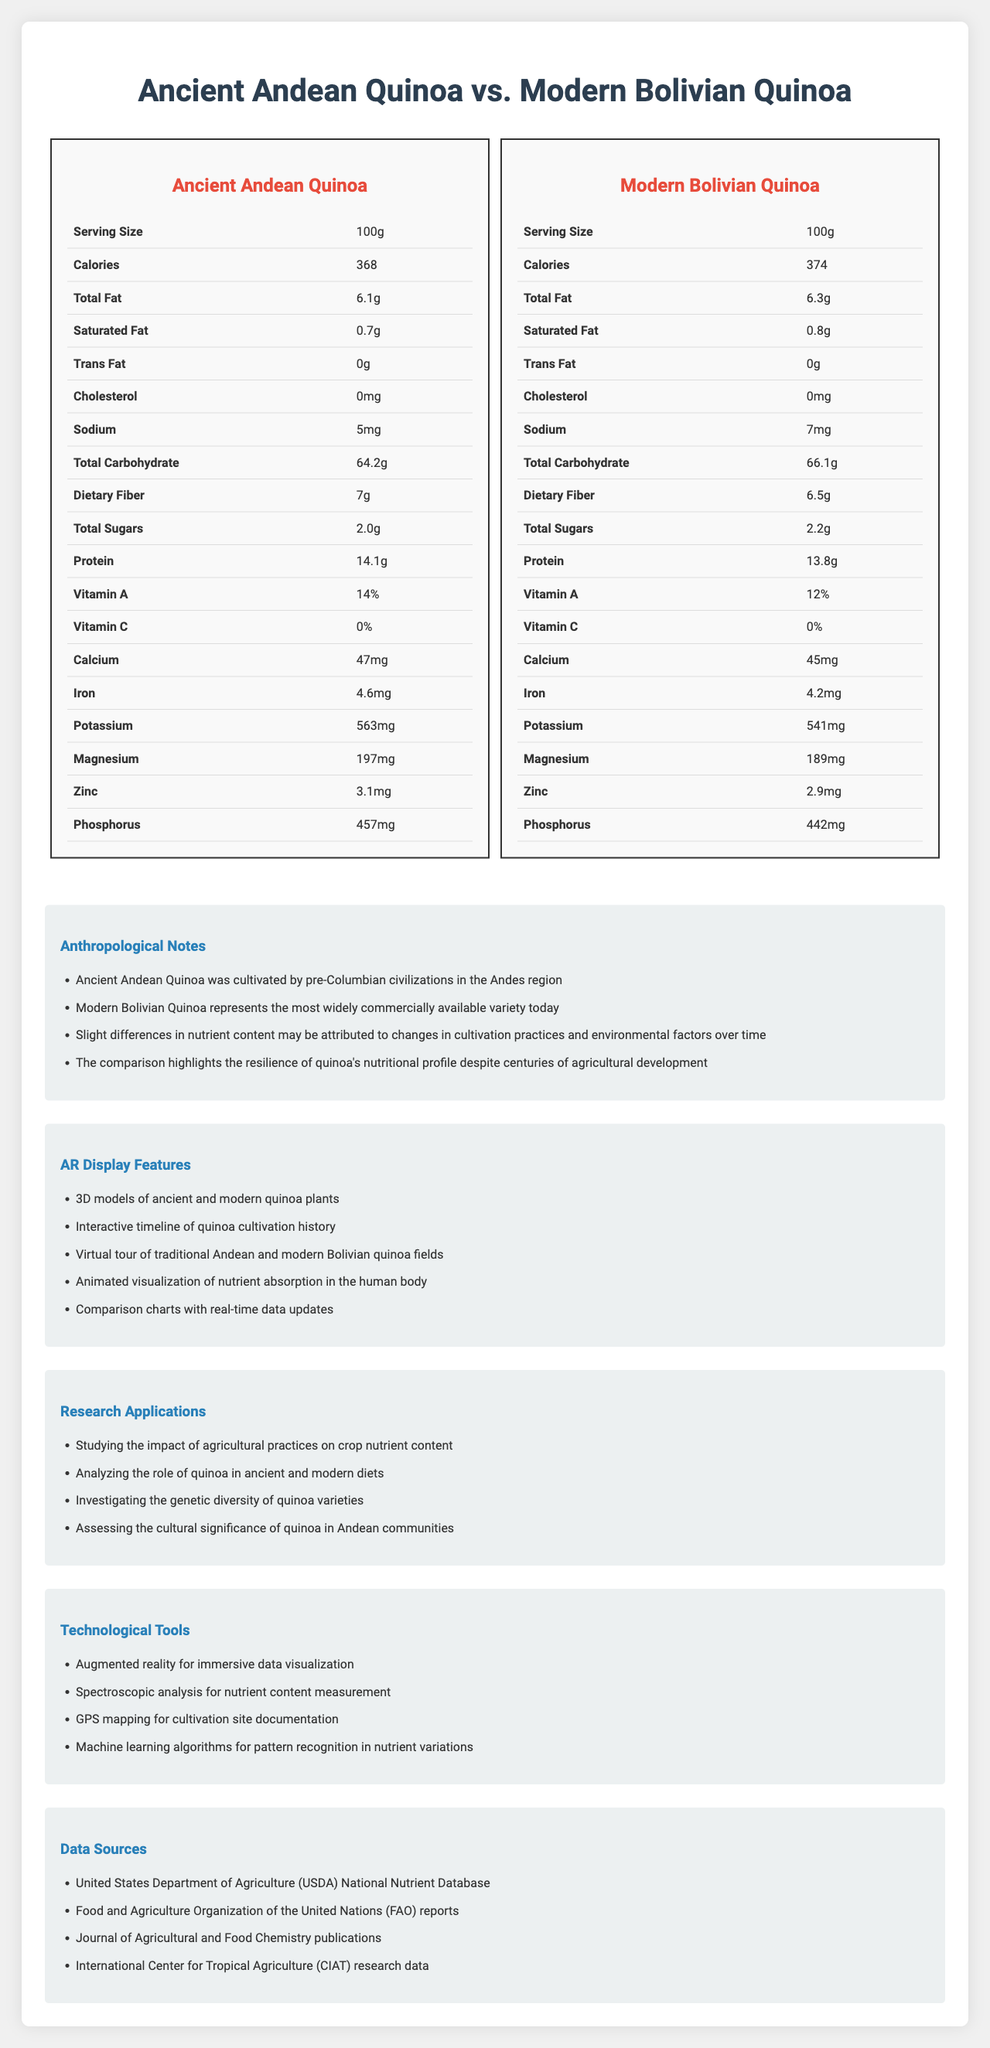what is the serving size for both quinoa varieties? The document specifies the serving size as 100g for both Ancient Andean Quinoa and Modern Bolivian Quinoa.
Answer: 100g which quinoa variety has higher protein content? The Ancient Andean Quinoa has 14.1g of protein compared to the Modern Bolivian Quinoa which has 13.8g of protein.
Answer: Ancient Andean Quinoa how many calories are in the Modern Bolivian Quinoa? According to the document, the Modern Bolivian Quinoa has 374 calories per 100g serving.
Answer: 374 what are some AR display features mentioned in the document? These features are listed under the "AR Display Features" section in the document.
Answer: 3D models of ancient and modern quinoa plants, Interactive timeline of quinoa cultivation history, Virtual tour of traditional Andean and modern Bolivian quinoa fields, Animated visualization of nutrient absorption in the human body, Comparison charts with real-time data updates how much iron is in the Ancient Andean Quinoa? The document lists the iron content for Ancient Andean Quinoa as 4.6mg per 100g serving.
Answer: 4.6mg which variety of quinoa has more dietary fiber? A. Ancient Andean Quinoa B. Modern Bolivian Quinoa Ancient Andean Quinoa has 7g of dietary fiber, while Modern Bolivian Quinoa has 6.5g.
Answer: A. Ancient Andean Quinoa which vitamin has identical content in both quinoa varieties? A. Vitamin A B. Vitamin C C. Calcium Both varieties have 0% Vitamin C as stated in the document.
Answer: B. Vitamin C is there any trans fat in either quinoa variety? The document specifies 0g of trans fat for both Ancient Andean Quinoa and Modern Bolivian Quinoa.
Answer: No summarize the main idea of the document. The comparison of quinoa varieties delves into their nutritional content, historical cultivation practices, and technological advancements in data visualization and measurement.
Answer: The document compares the nutritional content of Ancient Andean Quinoa and Modern Bolivian Quinoa. It highlights differences and similarities in their nutrient profiles, provides anthropological notes on the cultivation history of quinoa, elaborates on AR display features for visualization, and lists research applications and technological tools used in the analysis. what are some sources of data for the nutritional content in the document? These sources are explicitly mentioned under the "Data Sources" section.
Answer: USDA National Nutrient Database, FAO reports, Journal of Agricultural and Food Chemistry publications, CIAT research data what is the average daily recommendation of protein intake? The document does not provide information regarding recommended daily protein intake.
Answer: Cannot be determined which quinoa variety has a higher potassium content? The Ancient Andean Quinoa has 563mg of potassium, while the Modern Bolivian Quinoa has 541mg, indicating that the Ancient variety has higher potassium content.
Answer: Ancient Andean Quinoa 